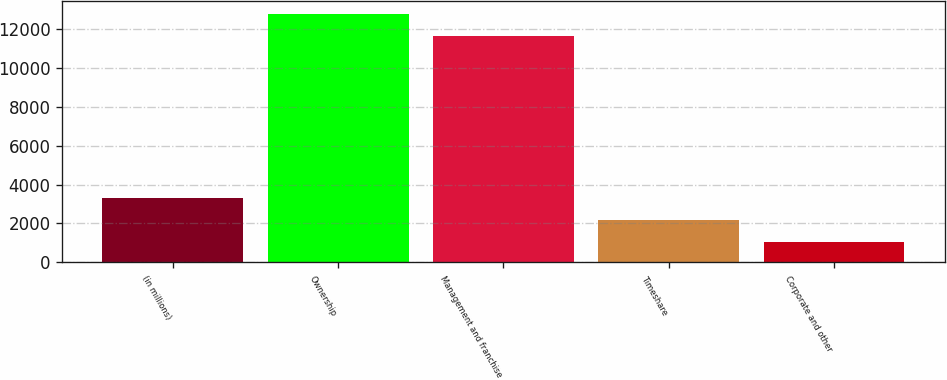Convert chart. <chart><loc_0><loc_0><loc_500><loc_500><bar_chart><fcel>(in millions)<fcel>Ownership<fcel>Management and franchise<fcel>Timeshare<fcel>Corporate and other<nl><fcel>3318.4<fcel>12794.7<fcel>11650<fcel>2173.7<fcel>1029<nl></chart> 